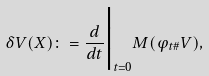<formula> <loc_0><loc_0><loc_500><loc_500>\delta V ( X ) \colon = \frac { d } { d t } \Big | _ { t = 0 } M ( \varphi _ { t \# } V ) ,</formula> 